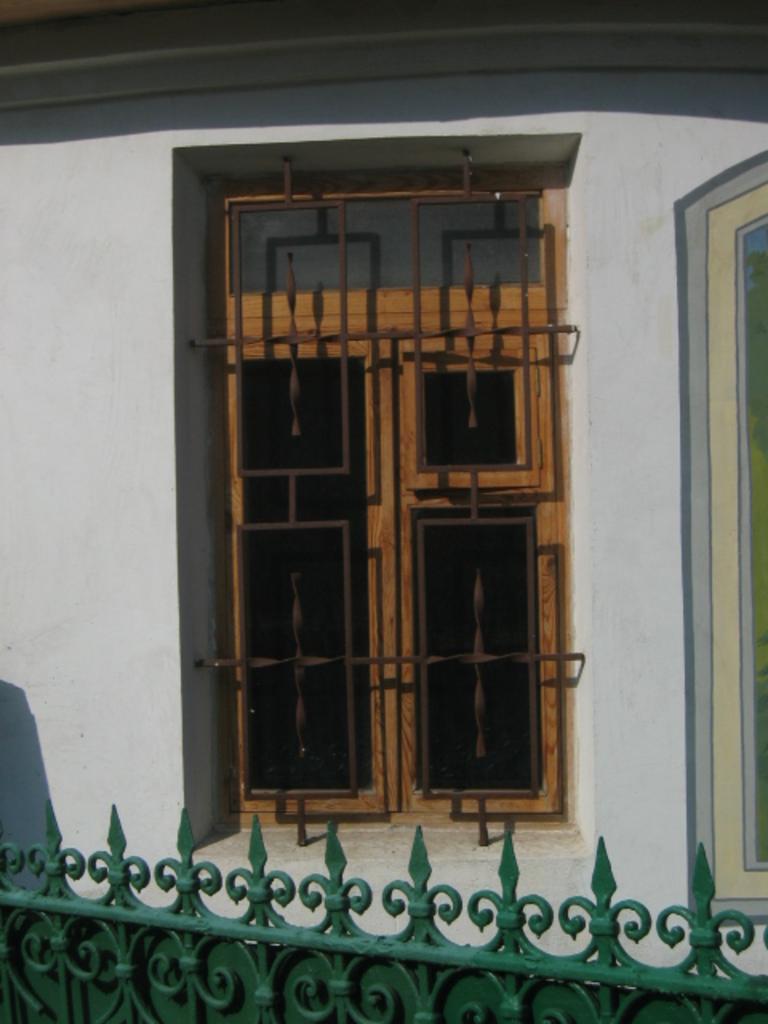Please provide a concise description of this image. In the foreground of this picture, there is a green gate. In the background, there is a closed window and a wall. 